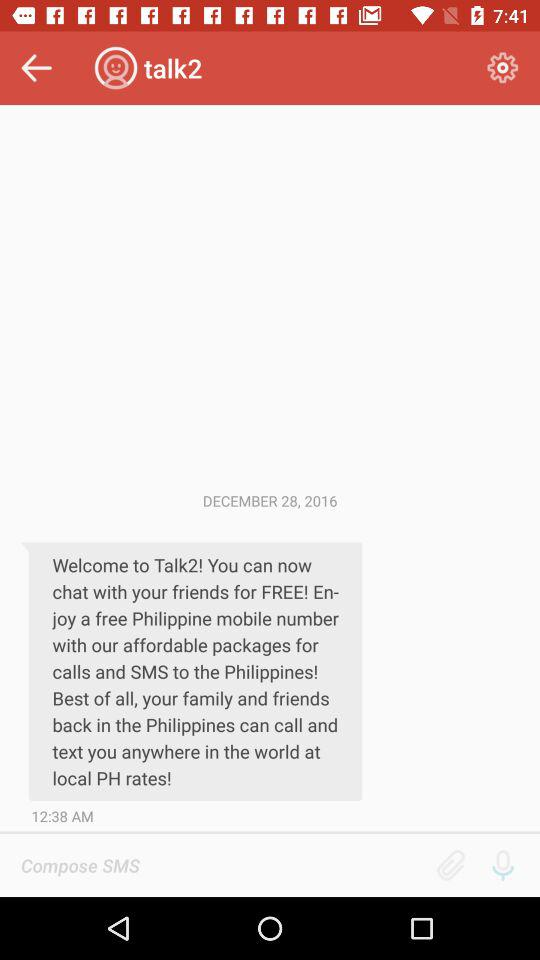At what time was the message received? The message was received at 12:38 a.m. 